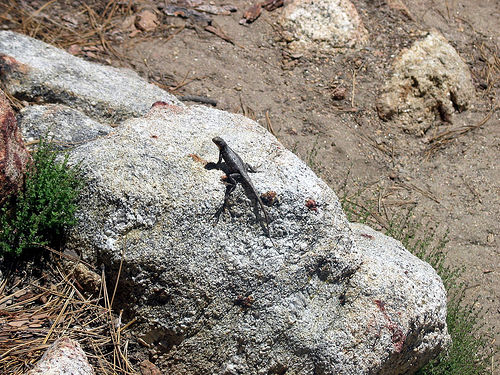<image>
Is the lizard on the rock? Yes. Looking at the image, I can see the lizard is positioned on top of the rock, with the rock providing support. 